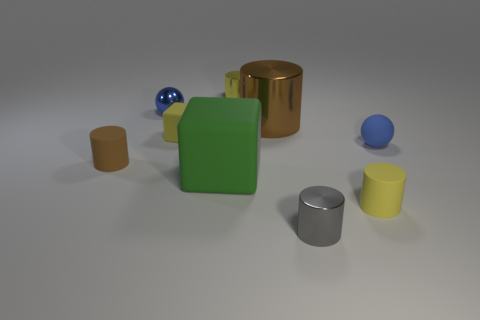Subtract all gray cylinders. How many cylinders are left? 4 Subtract all brown matte cylinders. How many cylinders are left? 4 Subtract all cyan cylinders. Subtract all green blocks. How many cylinders are left? 5 Add 1 small blue cylinders. How many objects exist? 10 Subtract all cubes. How many objects are left? 7 Subtract 0 brown blocks. How many objects are left? 9 Subtract all gray objects. Subtract all green things. How many objects are left? 7 Add 7 cubes. How many cubes are left? 9 Add 3 cyan metallic cylinders. How many cyan metallic cylinders exist? 3 